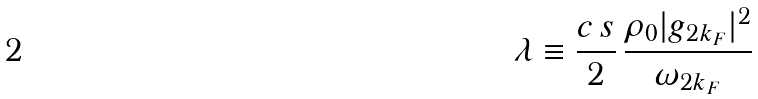Convert formula to latex. <formula><loc_0><loc_0><loc_500><loc_500>\lambda \equiv \frac { c \, s } { 2 } \, \frac { \rho _ { 0 } | g _ { 2 k _ { F } } | ^ { 2 } } { \omega _ { 2 k _ { F } } }</formula> 